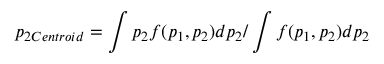<formula> <loc_0><loc_0><loc_500><loc_500>p _ { 2 C e n t r o i d } = \int p _ { 2 } f ( p _ { 1 } , p _ { 2 } ) d p _ { 2 } / \int f ( p _ { 1 } , p _ { 2 } ) d p _ { 2 }</formula> 